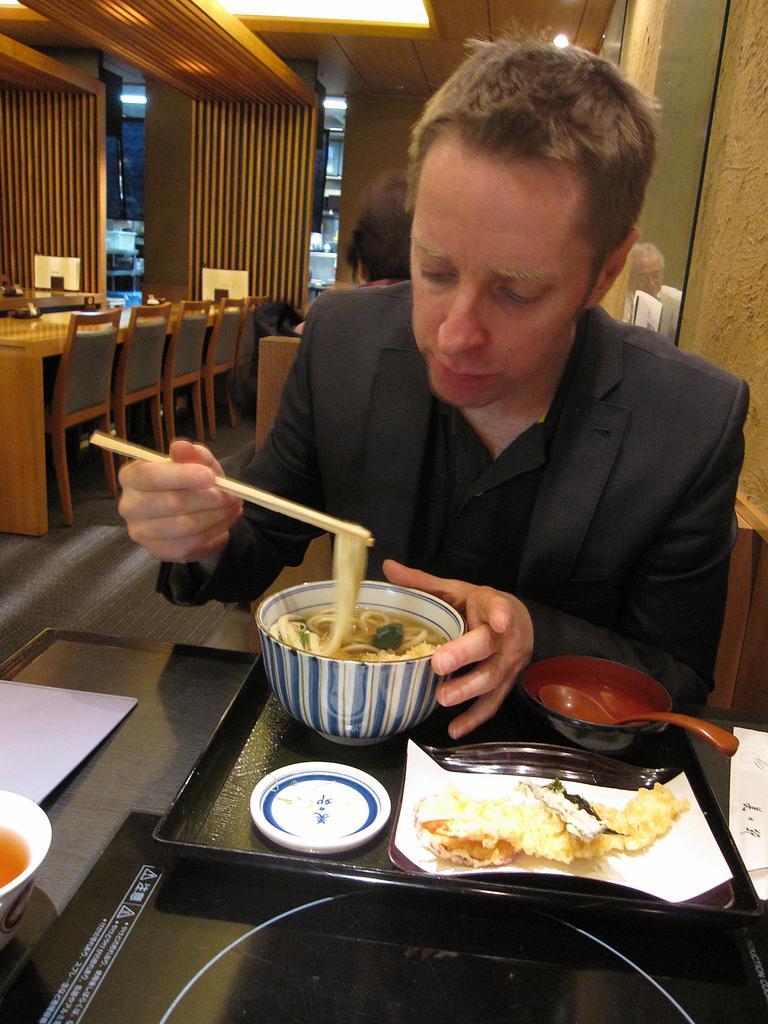In one or two sentences, can you explain what this image depicts? In the picture there is a man eating noodles with chopsticks,in front of him there is plate with other food,this seems to be in a hotel. Behind him there are few more people,on ceiling there are lights and over the left side of the image there are dining tables with chairs. 